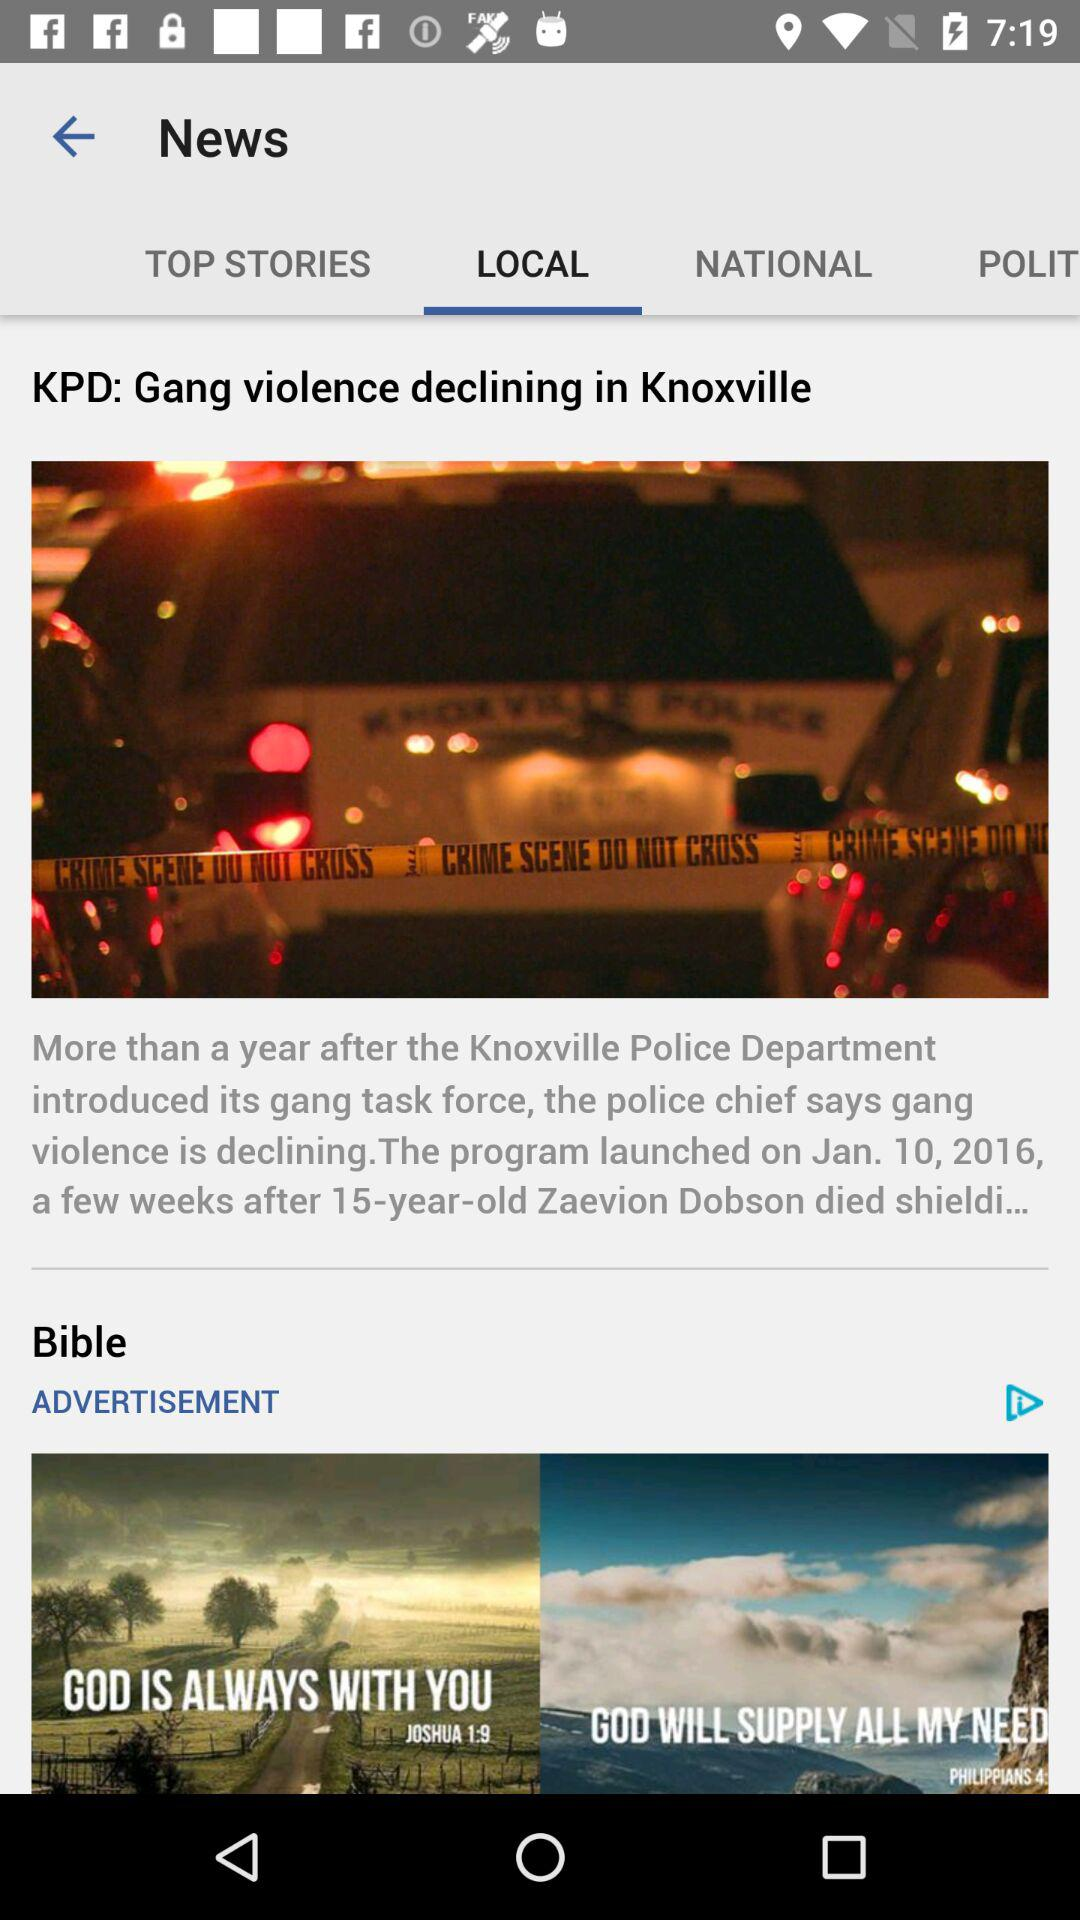Which tab is selected? The selected tab is "LOCAL". 